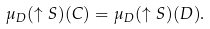<formula> <loc_0><loc_0><loc_500><loc_500>\mu _ { D } ( \uparrow S ) ( C ) = \mu _ { D } ( \uparrow S ) ( D ) .</formula> 